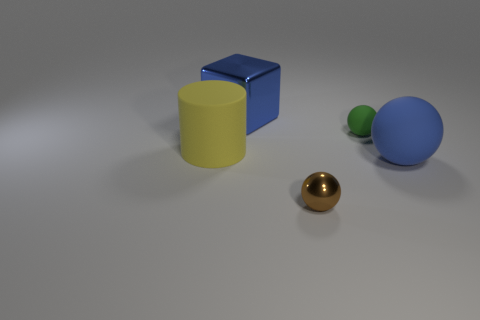What is the size of the brown shiny object that is the same shape as the green thing?
Offer a very short reply. Small. Are there any other things that have the same size as the yellow cylinder?
Give a very brief answer. Yes. There is a blue object that is to the right of the metallic object that is behind the cylinder; what is its material?
Your answer should be compact. Rubber. Is the shape of the big blue matte thing the same as the brown metal thing?
Your answer should be very brief. Yes. What number of spheres are on the right side of the brown metal sphere and in front of the big cylinder?
Ensure brevity in your answer.  1. Are there the same number of tiny brown balls behind the big ball and big cylinders that are in front of the large cylinder?
Make the answer very short. Yes. Is the size of the metal object that is in front of the large blue matte thing the same as the thing that is to the left of the large blue metal object?
Ensure brevity in your answer.  No. What is the object that is behind the yellow cylinder and right of the tiny brown metal object made of?
Offer a very short reply. Rubber. Is the number of small matte cylinders less than the number of large matte spheres?
Offer a very short reply. Yes. What size is the matte object left of the small thing on the left side of the tiny green object?
Keep it short and to the point. Large. 